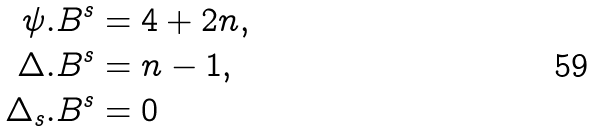Convert formula to latex. <formula><loc_0><loc_0><loc_500><loc_500>\psi . B ^ { s } & = 4 + 2 n , \\ \Delta . B ^ { s } & = n - 1 , \\ \Delta _ { s } . B ^ { s } & = 0</formula> 